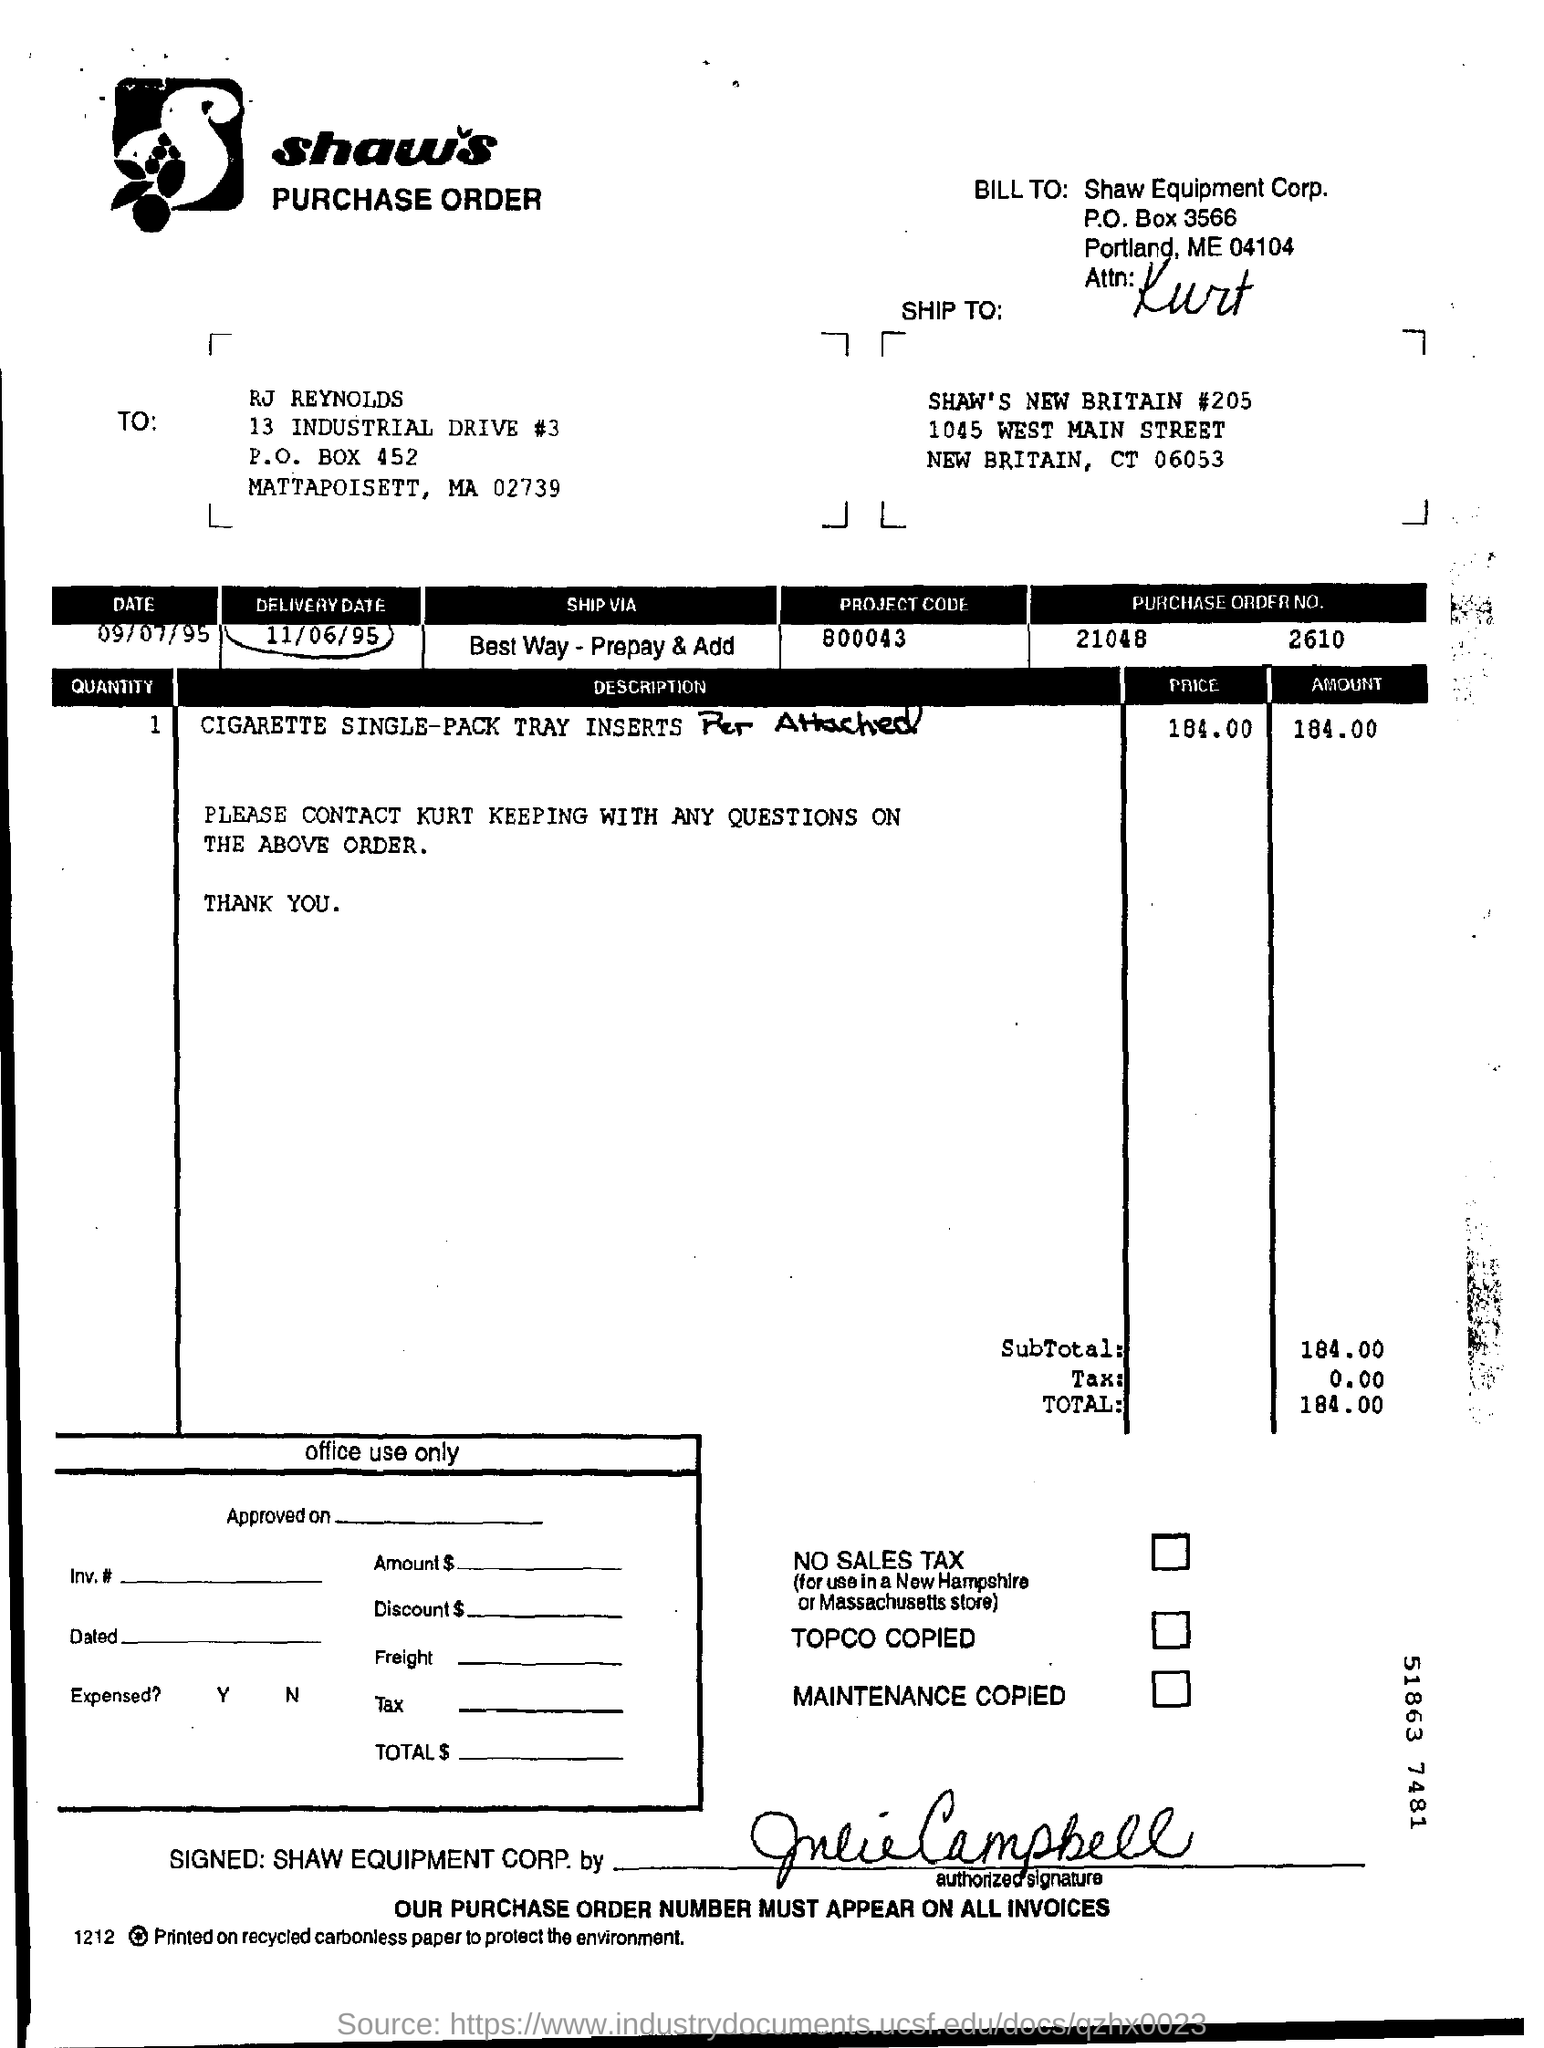How much is the total ?
Give a very brief answer. 184.00. What is the p.o box number of shaw equipment corp ?
Keep it short and to the point. 3566. Mention the delivery date ?
Your answer should be compact. 11/06/95. What is the project code ?
Ensure brevity in your answer.  800043. 